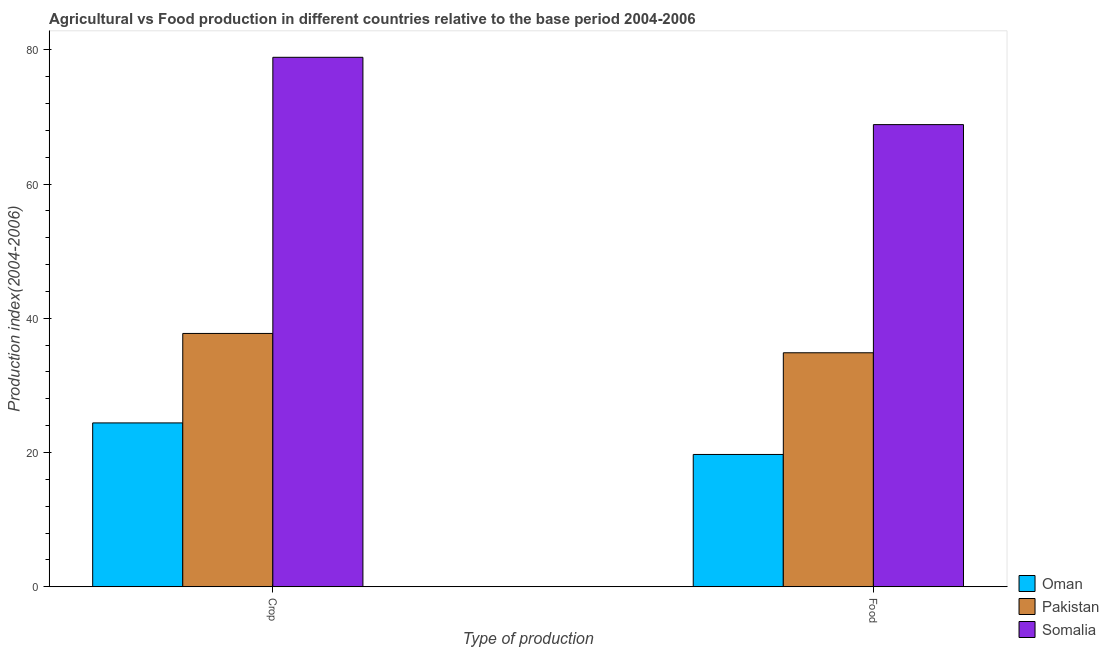How many different coloured bars are there?
Your answer should be compact. 3. How many bars are there on the 2nd tick from the left?
Offer a very short reply. 3. What is the label of the 2nd group of bars from the left?
Provide a short and direct response. Food. What is the crop production index in Oman?
Make the answer very short. 24.41. Across all countries, what is the maximum food production index?
Your answer should be compact. 68.85. Across all countries, what is the minimum crop production index?
Keep it short and to the point. 24.41. In which country was the food production index maximum?
Make the answer very short. Somalia. In which country was the food production index minimum?
Make the answer very short. Oman. What is the total food production index in the graph?
Provide a succinct answer. 123.42. What is the difference between the crop production index in Oman and that in Pakistan?
Provide a succinct answer. -13.33. What is the difference between the food production index in Somalia and the crop production index in Pakistan?
Offer a very short reply. 31.11. What is the average crop production index per country?
Make the answer very short. 47.01. What is the difference between the crop production index and food production index in Somalia?
Make the answer very short. 10.03. In how many countries, is the food production index greater than 60 ?
Offer a terse response. 1. What is the ratio of the crop production index in Oman to that in Pakistan?
Your response must be concise. 0.65. What does the 3rd bar from the right in Food represents?
Offer a very short reply. Oman. Are all the bars in the graph horizontal?
Provide a short and direct response. No. Are the values on the major ticks of Y-axis written in scientific E-notation?
Your answer should be very brief. No. Does the graph contain any zero values?
Offer a very short reply. No. How are the legend labels stacked?
Your response must be concise. Vertical. What is the title of the graph?
Give a very brief answer. Agricultural vs Food production in different countries relative to the base period 2004-2006. Does "Russian Federation" appear as one of the legend labels in the graph?
Your answer should be compact. No. What is the label or title of the X-axis?
Give a very brief answer. Type of production. What is the label or title of the Y-axis?
Your answer should be very brief. Production index(2004-2006). What is the Production index(2004-2006) of Oman in Crop?
Your answer should be very brief. 24.41. What is the Production index(2004-2006) of Pakistan in Crop?
Provide a succinct answer. 37.74. What is the Production index(2004-2006) in Somalia in Crop?
Offer a terse response. 78.88. What is the Production index(2004-2006) of Oman in Food?
Your answer should be very brief. 19.71. What is the Production index(2004-2006) in Pakistan in Food?
Your response must be concise. 34.86. What is the Production index(2004-2006) of Somalia in Food?
Your answer should be compact. 68.85. Across all Type of production, what is the maximum Production index(2004-2006) of Oman?
Offer a very short reply. 24.41. Across all Type of production, what is the maximum Production index(2004-2006) of Pakistan?
Give a very brief answer. 37.74. Across all Type of production, what is the maximum Production index(2004-2006) of Somalia?
Provide a short and direct response. 78.88. Across all Type of production, what is the minimum Production index(2004-2006) in Oman?
Your answer should be very brief. 19.71. Across all Type of production, what is the minimum Production index(2004-2006) in Pakistan?
Your response must be concise. 34.86. Across all Type of production, what is the minimum Production index(2004-2006) in Somalia?
Keep it short and to the point. 68.85. What is the total Production index(2004-2006) in Oman in the graph?
Keep it short and to the point. 44.12. What is the total Production index(2004-2006) in Pakistan in the graph?
Give a very brief answer. 72.6. What is the total Production index(2004-2006) of Somalia in the graph?
Provide a succinct answer. 147.73. What is the difference between the Production index(2004-2006) of Oman in Crop and that in Food?
Provide a succinct answer. 4.7. What is the difference between the Production index(2004-2006) of Pakistan in Crop and that in Food?
Your answer should be compact. 2.88. What is the difference between the Production index(2004-2006) of Somalia in Crop and that in Food?
Keep it short and to the point. 10.03. What is the difference between the Production index(2004-2006) of Oman in Crop and the Production index(2004-2006) of Pakistan in Food?
Provide a short and direct response. -10.45. What is the difference between the Production index(2004-2006) in Oman in Crop and the Production index(2004-2006) in Somalia in Food?
Your answer should be very brief. -44.44. What is the difference between the Production index(2004-2006) of Pakistan in Crop and the Production index(2004-2006) of Somalia in Food?
Ensure brevity in your answer.  -31.11. What is the average Production index(2004-2006) of Oman per Type of production?
Ensure brevity in your answer.  22.06. What is the average Production index(2004-2006) of Pakistan per Type of production?
Your answer should be compact. 36.3. What is the average Production index(2004-2006) of Somalia per Type of production?
Offer a terse response. 73.86. What is the difference between the Production index(2004-2006) of Oman and Production index(2004-2006) of Pakistan in Crop?
Your answer should be very brief. -13.33. What is the difference between the Production index(2004-2006) in Oman and Production index(2004-2006) in Somalia in Crop?
Make the answer very short. -54.47. What is the difference between the Production index(2004-2006) of Pakistan and Production index(2004-2006) of Somalia in Crop?
Provide a short and direct response. -41.14. What is the difference between the Production index(2004-2006) of Oman and Production index(2004-2006) of Pakistan in Food?
Provide a short and direct response. -15.15. What is the difference between the Production index(2004-2006) in Oman and Production index(2004-2006) in Somalia in Food?
Your answer should be very brief. -49.14. What is the difference between the Production index(2004-2006) of Pakistan and Production index(2004-2006) of Somalia in Food?
Your answer should be very brief. -33.99. What is the ratio of the Production index(2004-2006) of Oman in Crop to that in Food?
Make the answer very short. 1.24. What is the ratio of the Production index(2004-2006) in Pakistan in Crop to that in Food?
Make the answer very short. 1.08. What is the ratio of the Production index(2004-2006) in Somalia in Crop to that in Food?
Your response must be concise. 1.15. What is the difference between the highest and the second highest Production index(2004-2006) in Pakistan?
Your response must be concise. 2.88. What is the difference between the highest and the second highest Production index(2004-2006) of Somalia?
Keep it short and to the point. 10.03. What is the difference between the highest and the lowest Production index(2004-2006) of Oman?
Offer a terse response. 4.7. What is the difference between the highest and the lowest Production index(2004-2006) of Pakistan?
Keep it short and to the point. 2.88. What is the difference between the highest and the lowest Production index(2004-2006) in Somalia?
Offer a terse response. 10.03. 